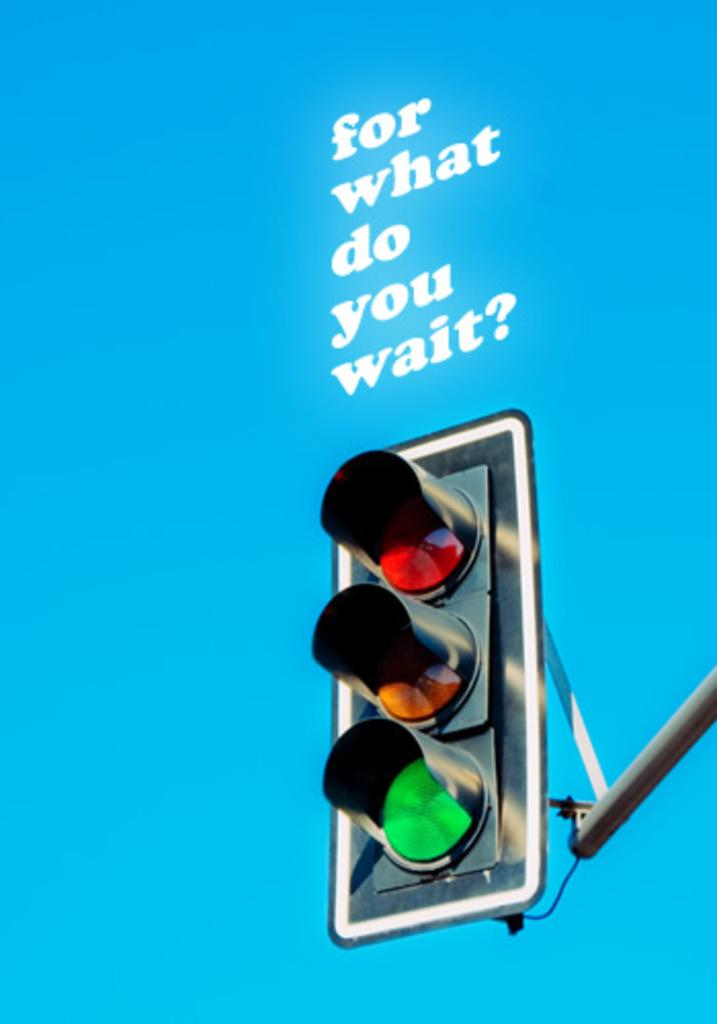<image>
Relay a brief, clear account of the picture shown. Traffic light with a saying on top that says "for what do you wait?". 